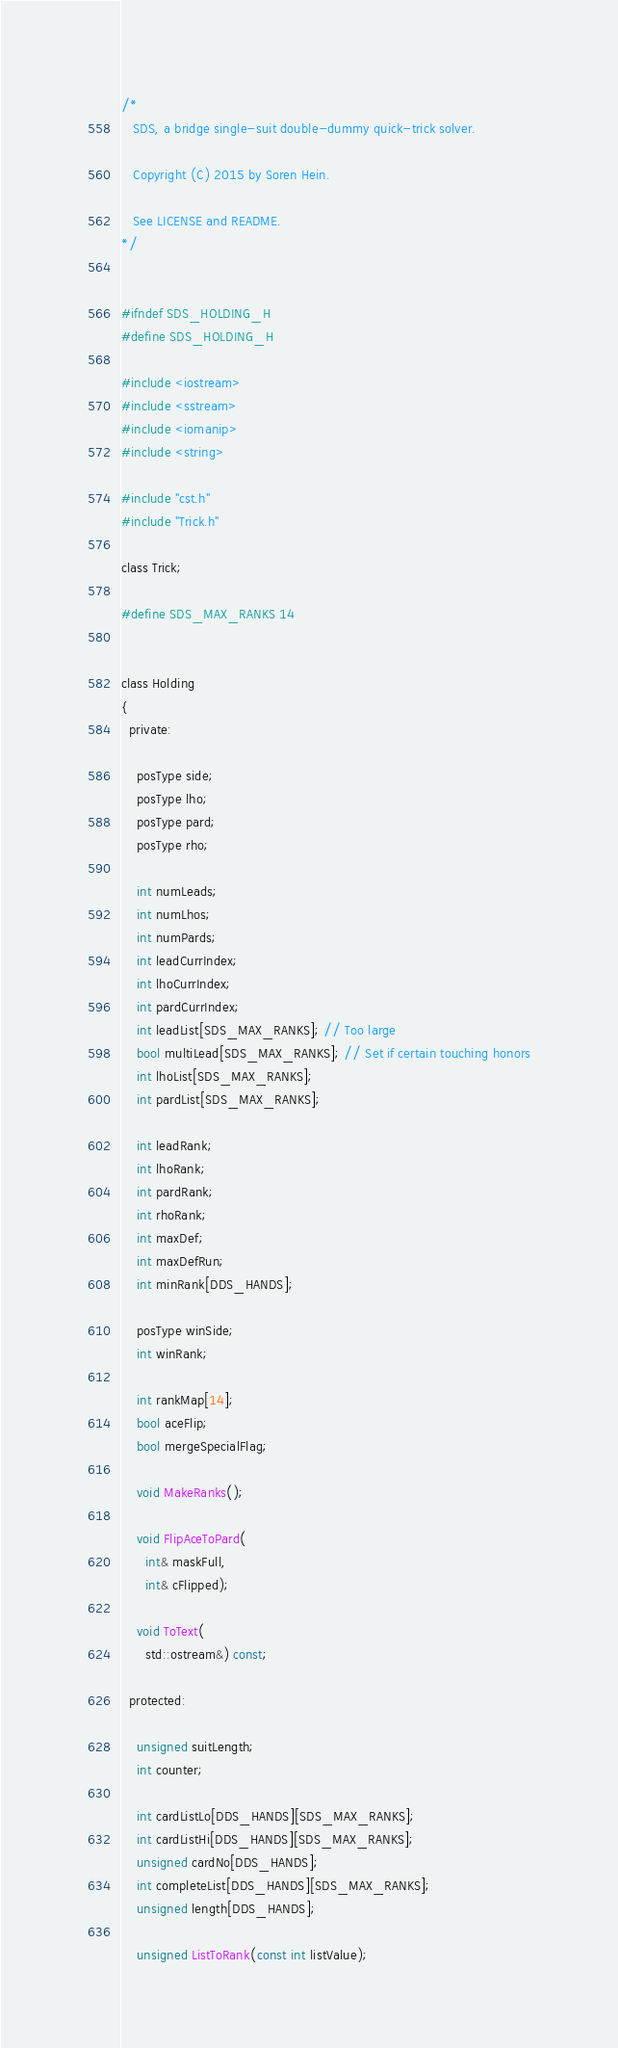Convert code to text. <code><loc_0><loc_0><loc_500><loc_500><_C_>/* 
   SDS, a bridge single-suit double-dummy quick-trick solver.

   Copyright (C) 2015 by Soren Hein.

   See LICENSE and README.
*/


#ifndef SDS_HOLDING_H
#define SDS_HOLDING_H

#include <iostream>
#include <sstream>
#include <iomanip>
#include <string>

#include "cst.h"
#include "Trick.h"

class Trick;

#define SDS_MAX_RANKS 14


class Holding
{
  private:

    posType side;
    posType lho;
    posType pard;
    posType rho;

    int numLeads;
    int numLhos;
    int numPards;
    int leadCurrIndex;
    int lhoCurrIndex;
    int pardCurrIndex;
    int leadList[SDS_MAX_RANKS]; // Too large
    bool multiLead[SDS_MAX_RANKS]; // Set if certain touching honors
    int lhoList[SDS_MAX_RANKS];
    int pardList[SDS_MAX_RANKS];

    int leadRank;
    int lhoRank;
    int pardRank;
    int rhoRank;
    int maxDef;
    int maxDefRun;
    int minRank[DDS_HANDS];

    posType winSide;
    int winRank;

    int rankMap[14];
    bool aceFlip;
    bool mergeSpecialFlag;

    void MakeRanks();

    void FlipAceToPard(
      int& maskFull,
      int& cFlipped);

    void ToText(
      std::ostream&) const;

  protected:

    unsigned suitLength;
    int counter;

    int cardListLo[DDS_HANDS][SDS_MAX_RANKS];
    int cardListHi[DDS_HANDS][SDS_MAX_RANKS];
    unsigned cardNo[DDS_HANDS];
    int completeList[DDS_HANDS][SDS_MAX_RANKS];
    unsigned length[DDS_HANDS];

    unsigned ListToRank(const int listValue);
</code> 